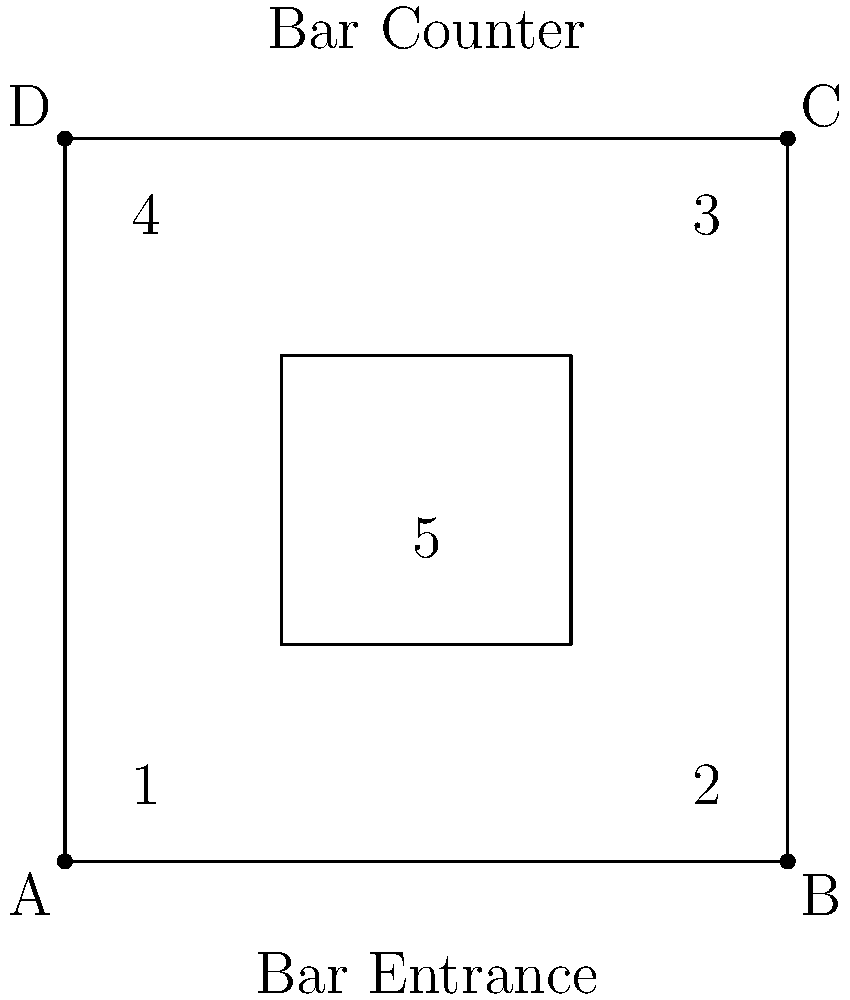In the layout of your wine bar shown above, where would be the most effective placement for promotional signage to maximize customer attention? Consider that customers enter from the bottom of the diagram and the bar counter is at the top. To determine the most effective placement for promotional signage, we need to consider customer flow and visibility:

1. Position 1 (bottom-left corner):
   - Pros: Near the entrance, immediately visible upon entry.
   - Cons: May be easily overlooked as customers move further into the bar.

2. Position 2 (bottom-right corner):
   - Pros: Visible from the entrance, catches eye as customers scan the room.
   - Cons: May be missed by those heading directly to the bar counter.

3. Position 3 (top-right corner):
   - Pros: Visible from most of the bar area.
   - Cons: Far from the entrance, may be missed by customers who don't look up.

4. Position 4 (top-left corner):
   - Pros: Visible from most of the bar area.
   - Cons: Far from the entrance, may be missed by customers who don't look up.

5. Position 5 (center):
   - Pros: Central location, visible from all angles.
   - Cons: May interfere with customer movement and seating arrangements.

Considering these factors, Position 2 (bottom-right corner) is the most effective placement because:
a) It's visible upon entry without obstructing the path.
b) It's in the natural line of sight as customers scan the room.
c) It doesn't interfere with the central space or seating arrangements.
d) It's close enough to the entrance to catch immediate attention but not so close that it's overlooked.
Answer: Position 2 (bottom-right corner) 